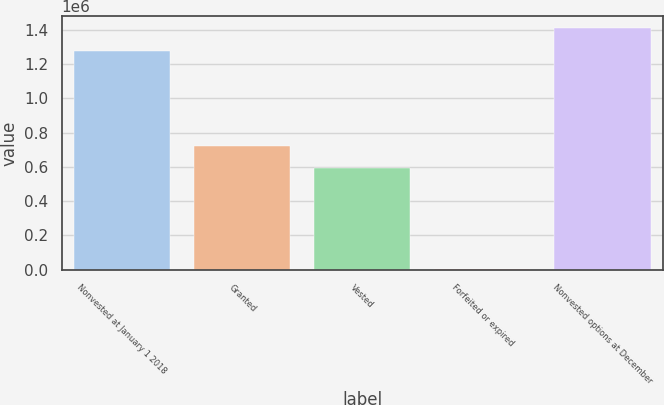<chart> <loc_0><loc_0><loc_500><loc_500><bar_chart><fcel>Nonvested at January 1 2018<fcel>Granted<fcel>Vested<fcel>Forfeited or expired<fcel>Nonvested options at December<nl><fcel>1.2786e+06<fcel>723660<fcel>594300<fcel>5200<fcel>1.40796e+06<nl></chart> 